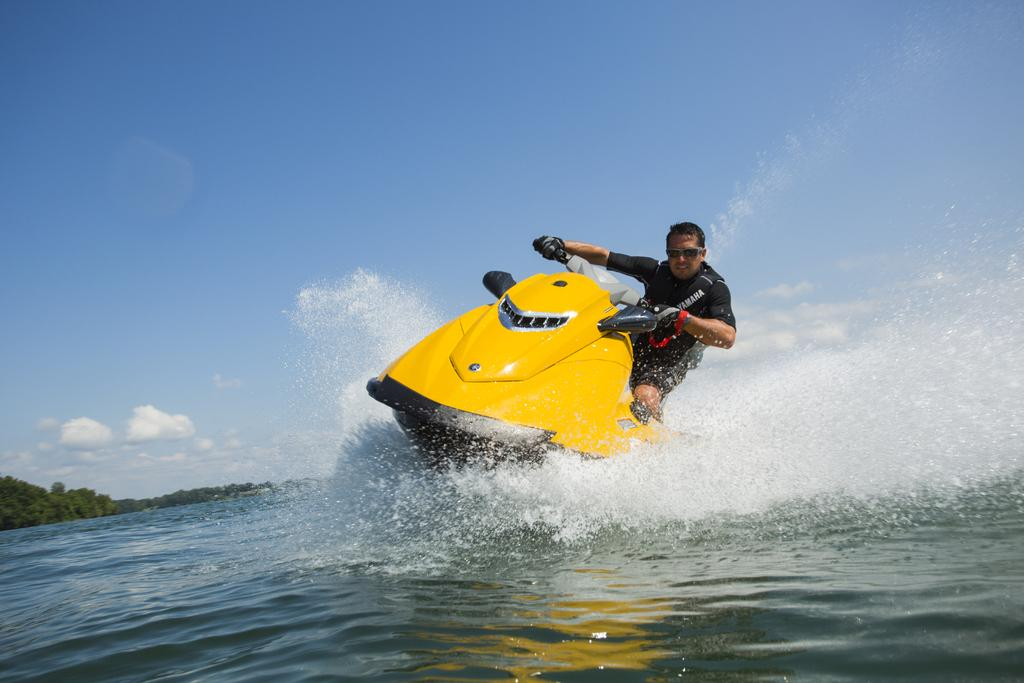What is the person in the image doing? There is a person riding a ship in the image. Where is the ship located? The ship is in the water. What can be seen on the left side of the image? There are trees on the left side of the image. What is visible in the background of the image? The sky is visible in the background of the image. What type of butter is being used to grease the donkey's hooves in the image? There is no donkey or butter present in the image; it features a person riding a ship in the water. 